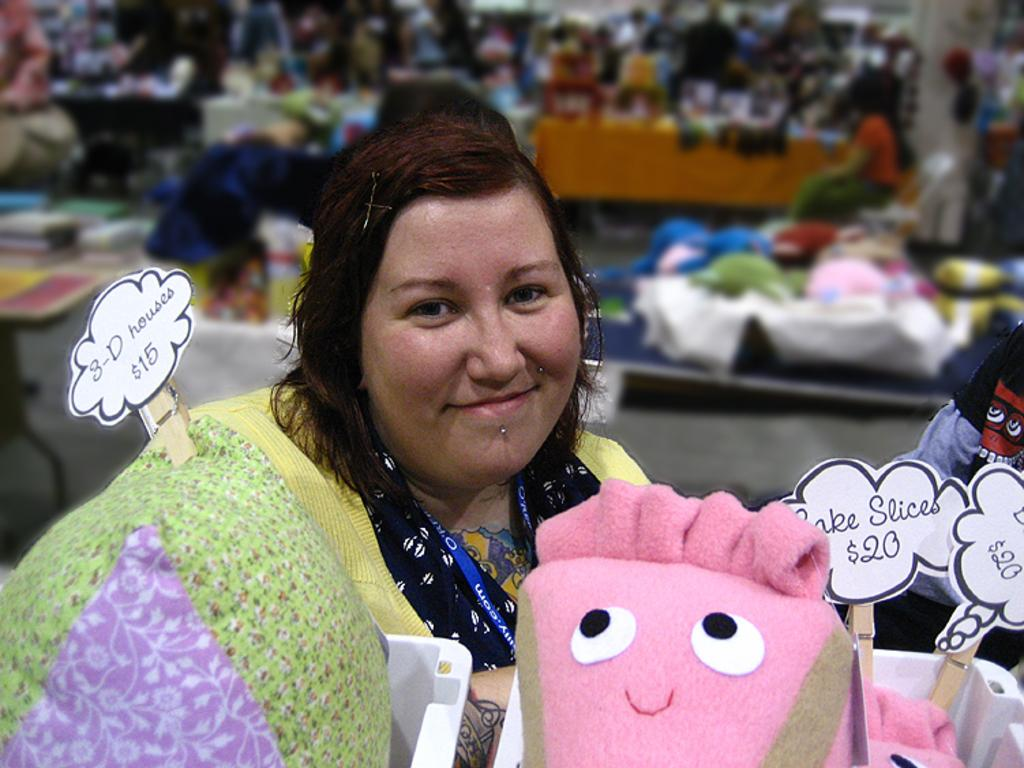Who is present in the image? There is a woman in the image. What is the woman doing in the image? The woman is smiling. What objects can be seen in the image? There is a pillow, a toy, and boards visible in the image. Can you describe the background of the image? The background of the image is blurred, and there are few persons and objects visible. What type of flesh can be seen in the image? There is no flesh visible in the image; it features a woman, a pillow, a toy, and boards. What kind of tub is present in the image? There is no tub present in the image. 